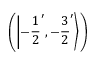<formula> <loc_0><loc_0><loc_500><loc_500>\left ( \left | - { \frac { 1 } { 2 } } ^ { \prime } , - { \frac { 3 } { 2 } } ^ { \prime } \right \rangle \right )</formula> 